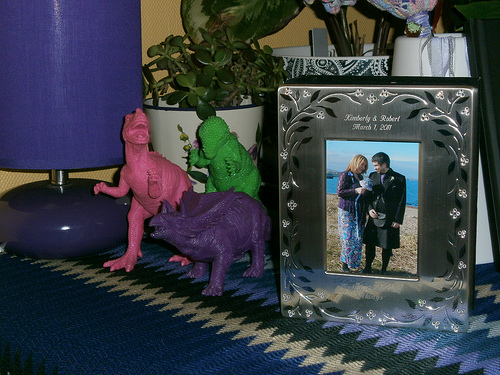<image>
Can you confirm if the table cloth is to the left of the picture frame? No. The table cloth is not to the left of the picture frame. From this viewpoint, they have a different horizontal relationship. 